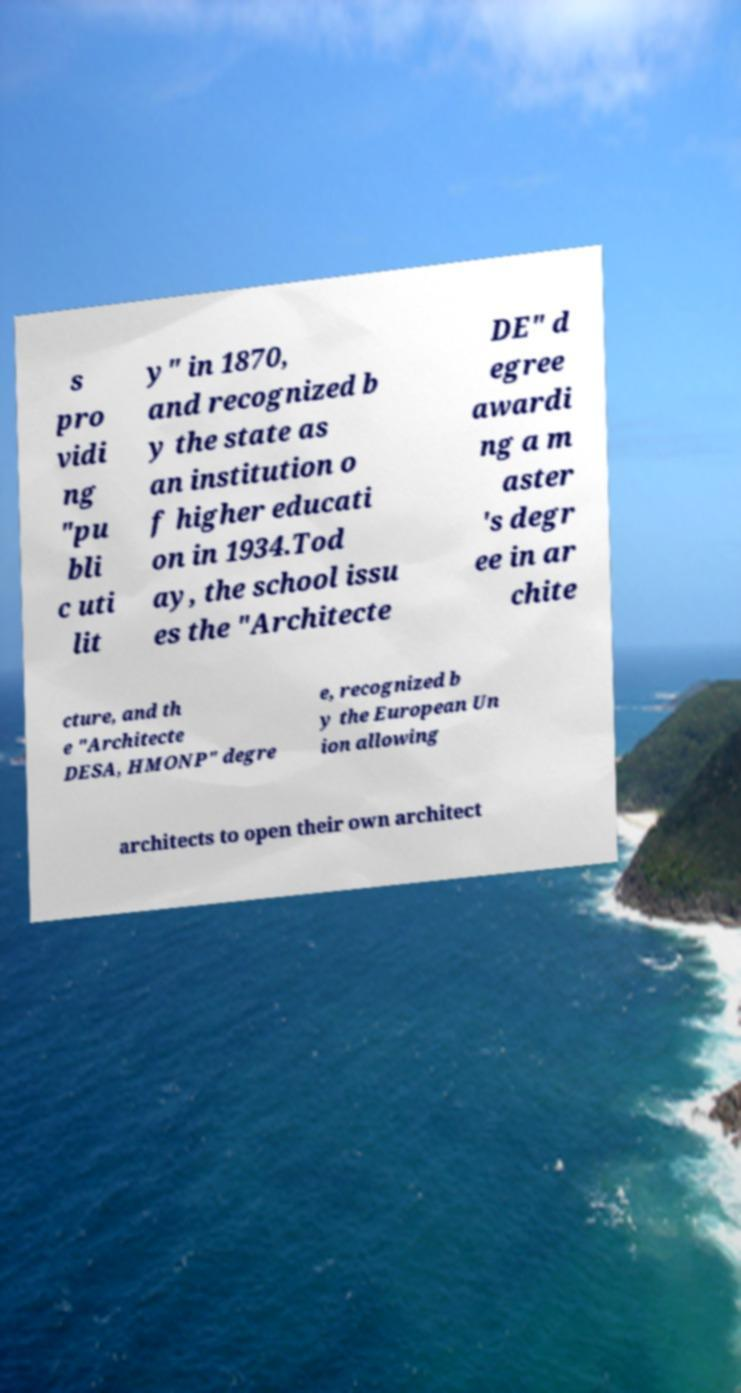Can you read and provide the text displayed in the image?This photo seems to have some interesting text. Can you extract and type it out for me? s pro vidi ng "pu bli c uti lit y" in 1870, and recognized b y the state as an institution o f higher educati on in 1934.Tod ay, the school issu es the "Architecte DE" d egree awardi ng a m aster 's degr ee in ar chite cture, and th e "Architecte DESA, HMONP" degre e, recognized b y the European Un ion allowing architects to open their own architect 